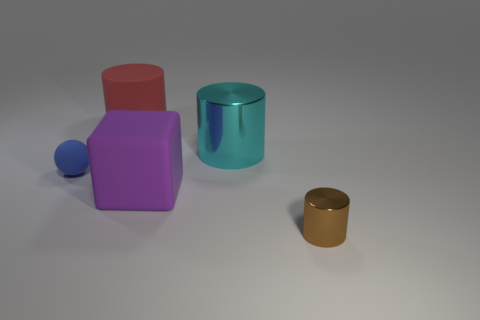Add 5 large metal cylinders. How many objects exist? 10 Subtract all spheres. How many objects are left? 4 Subtract 0 red spheres. How many objects are left? 5 Subtract all large red rubber cylinders. Subtract all rubber spheres. How many objects are left? 3 Add 1 rubber balls. How many rubber balls are left? 2 Add 1 big brown metallic cubes. How many big brown metallic cubes exist? 1 